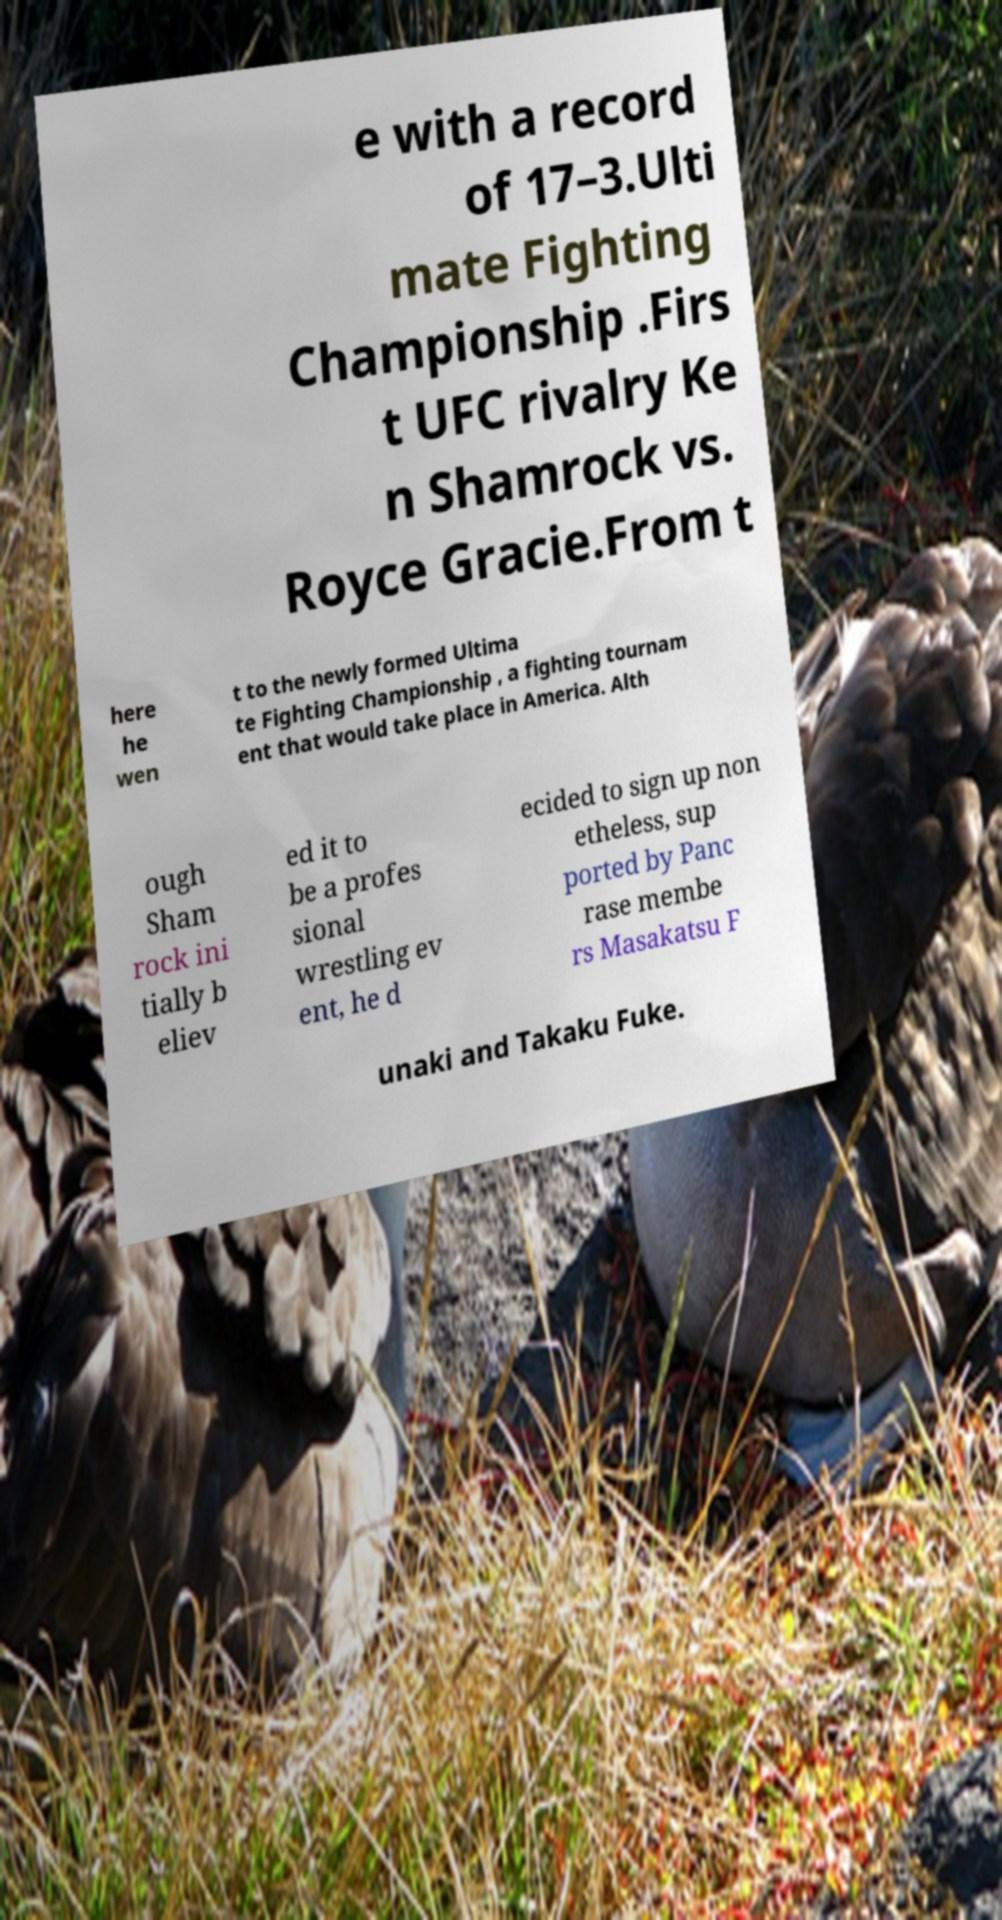There's text embedded in this image that I need extracted. Can you transcribe it verbatim? e with a record of 17–3.Ulti mate Fighting Championship .Firs t UFC rivalry Ke n Shamrock vs. Royce Gracie.From t here he wen t to the newly formed Ultima te Fighting Championship , a fighting tournam ent that would take place in America. Alth ough Sham rock ini tially b eliev ed it to be a profes sional wrestling ev ent, he d ecided to sign up non etheless, sup ported by Panc rase membe rs Masakatsu F unaki and Takaku Fuke. 